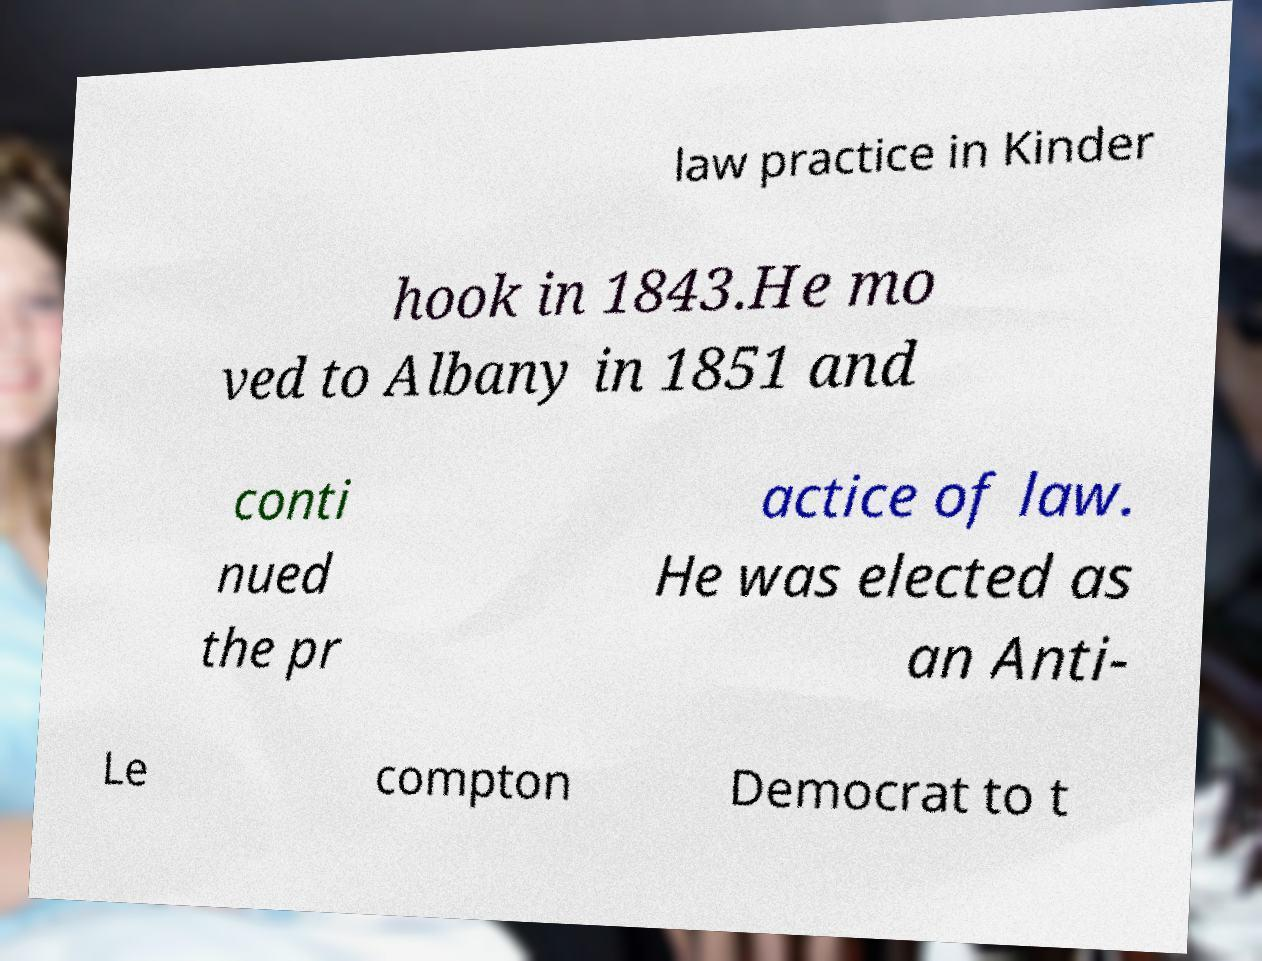Could you extract and type out the text from this image? law practice in Kinder hook in 1843.He mo ved to Albany in 1851 and conti nued the pr actice of law. He was elected as an Anti- Le compton Democrat to t 